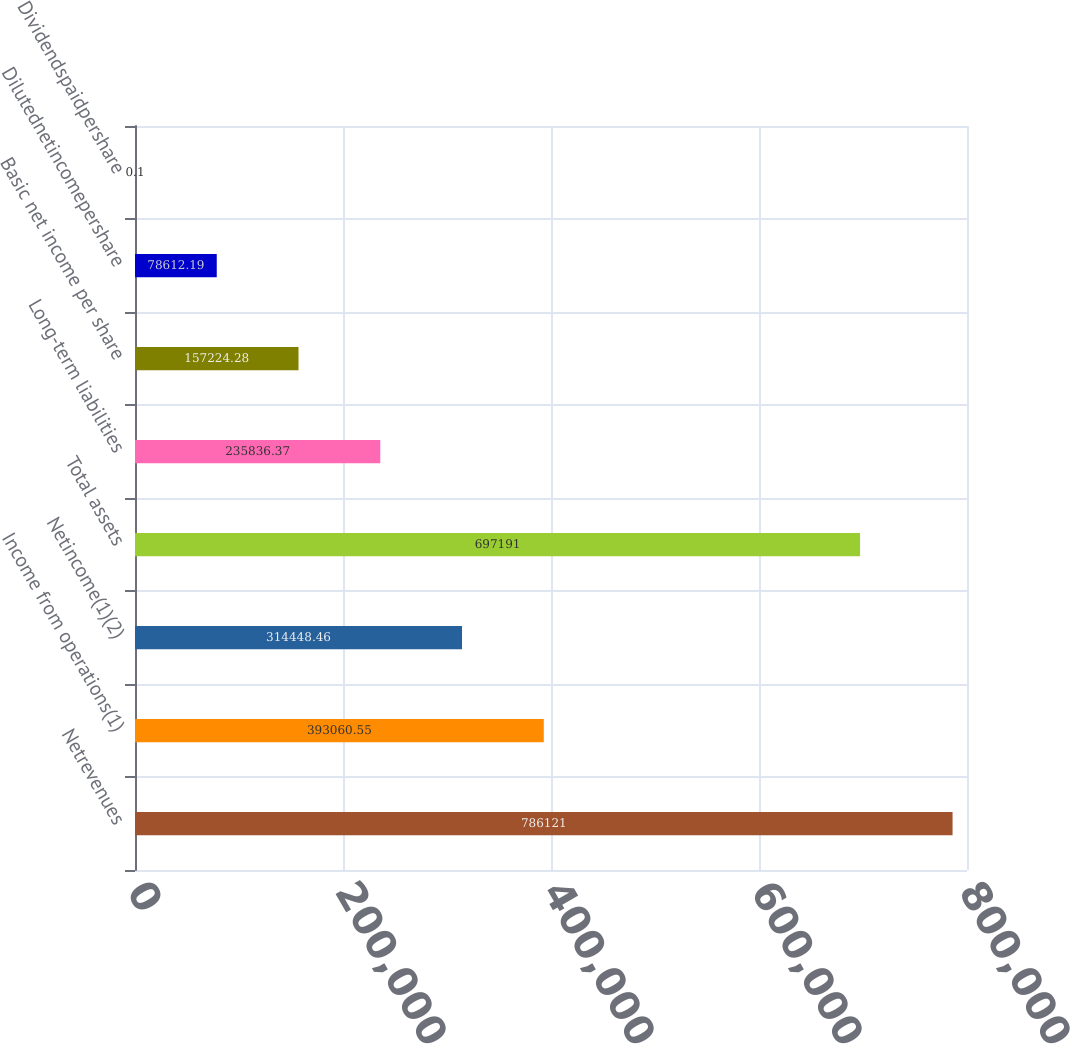<chart> <loc_0><loc_0><loc_500><loc_500><bar_chart><fcel>Netrevenues<fcel>Income from operations(1)<fcel>Netincome(1)(2)<fcel>Total assets<fcel>Long-term liabilities<fcel>Basic net income per share<fcel>Dilutednetincomepershare<fcel>Dividendspaidpershare<nl><fcel>786121<fcel>393061<fcel>314448<fcel>697191<fcel>235836<fcel>157224<fcel>78612.2<fcel>0.1<nl></chart> 